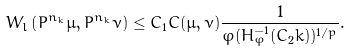Convert formula to latex. <formula><loc_0><loc_0><loc_500><loc_500>W _ { l } \left ( P ^ { n _ { k } } \mu , P ^ { n _ { k } } \nu \right ) \leq C _ { 1 } C ( \mu , \nu ) \frac { 1 } { \varphi ( H _ { \varphi } ^ { - 1 } ( C _ { 2 } k ) ) ^ { 1 / p } } .</formula> 